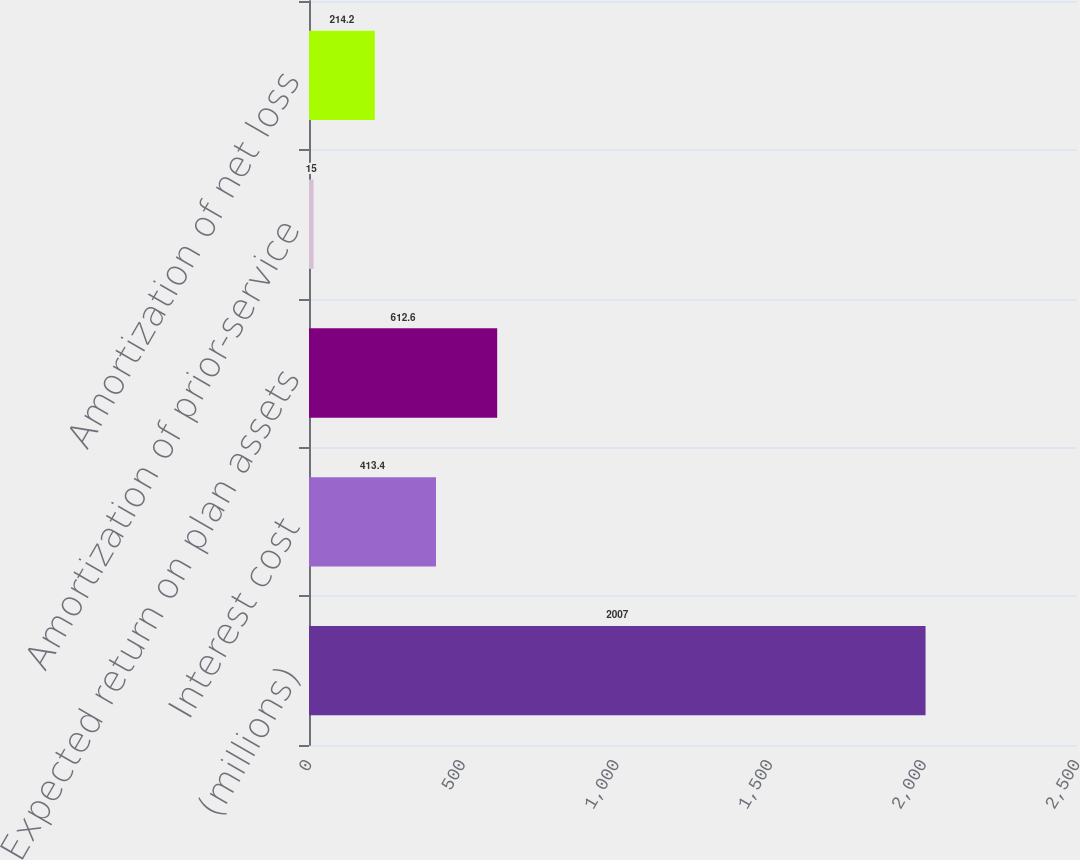<chart> <loc_0><loc_0><loc_500><loc_500><bar_chart><fcel>(millions)<fcel>Interest cost<fcel>Expected return on plan assets<fcel>Amortization of prior-service<fcel>Amortization of net loss<nl><fcel>2007<fcel>413.4<fcel>612.6<fcel>15<fcel>214.2<nl></chart> 